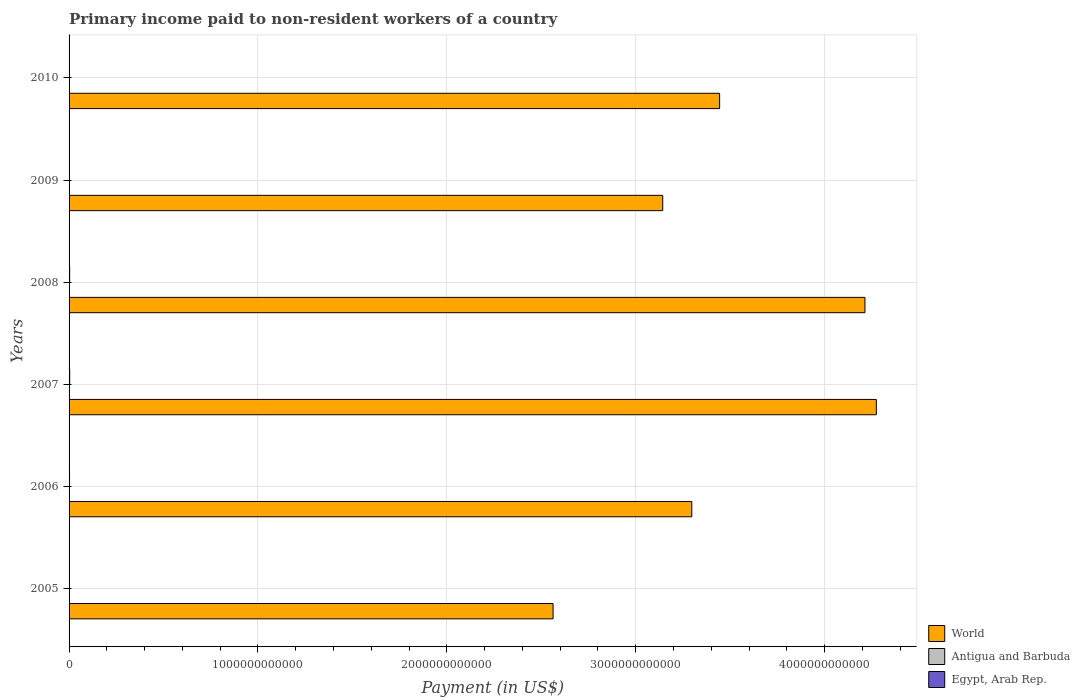How many groups of bars are there?
Provide a short and direct response. 6. Are the number of bars per tick equal to the number of legend labels?
Your answer should be very brief. Yes. How many bars are there on the 3rd tick from the top?
Give a very brief answer. 3. How many bars are there on the 3rd tick from the bottom?
Make the answer very short. 3. What is the label of the 6th group of bars from the top?
Your answer should be compact. 2005. What is the amount paid to workers in Egypt, Arab Rep. in 2006?
Keep it short and to the point. 2.56e+09. Across all years, what is the maximum amount paid to workers in Antigua and Barbuda?
Provide a short and direct response. 2.67e+07. Across all years, what is the minimum amount paid to workers in Antigua and Barbuda?
Keep it short and to the point. 1.11e+07. In which year was the amount paid to workers in World maximum?
Give a very brief answer. 2007. What is the total amount paid to workers in Antigua and Barbuda in the graph?
Provide a short and direct response. 1.11e+08. What is the difference between the amount paid to workers in World in 2008 and that in 2010?
Provide a short and direct response. 7.69e+11. What is the difference between the amount paid to workers in World in 2010 and the amount paid to workers in Egypt, Arab Rep. in 2008?
Your answer should be very brief. 3.44e+12. What is the average amount paid to workers in Antigua and Barbuda per year?
Make the answer very short. 1.85e+07. In the year 2010, what is the difference between the amount paid to workers in Egypt, Arab Rep. and amount paid to workers in World?
Offer a very short reply. -3.44e+12. In how many years, is the amount paid to workers in Egypt, Arab Rep. greater than 600000000000 US$?
Offer a very short reply. 0. What is the ratio of the amount paid to workers in World in 2007 to that in 2008?
Give a very brief answer. 1.01. Is the amount paid to workers in Antigua and Barbuda in 2008 less than that in 2009?
Make the answer very short. No. What is the difference between the highest and the second highest amount paid to workers in World?
Your answer should be compact. 6.03e+1. What is the difference between the highest and the lowest amount paid to workers in World?
Ensure brevity in your answer.  1.71e+12. Is the sum of the amount paid to workers in Antigua and Barbuda in 2007 and 2009 greater than the maximum amount paid to workers in World across all years?
Make the answer very short. No. What does the 1st bar from the top in 2009 represents?
Offer a very short reply. Egypt, Arab Rep. How many bars are there?
Ensure brevity in your answer.  18. Are all the bars in the graph horizontal?
Your answer should be very brief. Yes. How many years are there in the graph?
Your response must be concise. 6. What is the difference between two consecutive major ticks on the X-axis?
Provide a short and direct response. 1.00e+12. Are the values on the major ticks of X-axis written in scientific E-notation?
Offer a very short reply. No. Does the graph contain grids?
Offer a very short reply. Yes. Where does the legend appear in the graph?
Provide a short and direct response. Bottom right. How many legend labels are there?
Give a very brief answer. 3. How are the legend labels stacked?
Provide a short and direct response. Vertical. What is the title of the graph?
Keep it short and to the point. Primary income paid to non-resident workers of a country. Does "St. Vincent and the Grenadines" appear as one of the legend labels in the graph?
Offer a very short reply. No. What is the label or title of the X-axis?
Your answer should be compact. Payment (in US$). What is the Payment (in US$) in World in 2005?
Give a very brief answer. 2.56e+12. What is the Payment (in US$) in Antigua and Barbuda in 2005?
Your answer should be very brief. 1.80e+07. What is the Payment (in US$) in Egypt, Arab Rep. in 2005?
Keep it short and to the point. 1.43e+09. What is the Payment (in US$) of World in 2006?
Keep it short and to the point. 3.30e+12. What is the Payment (in US$) of Antigua and Barbuda in 2006?
Ensure brevity in your answer.  2.67e+07. What is the Payment (in US$) in Egypt, Arab Rep. in 2006?
Make the answer very short. 2.56e+09. What is the Payment (in US$) in World in 2007?
Your answer should be very brief. 4.27e+12. What is the Payment (in US$) of Antigua and Barbuda in 2007?
Your answer should be very brief. 2.58e+07. What is the Payment (in US$) in Egypt, Arab Rep. in 2007?
Offer a terse response. 3.31e+09. What is the Payment (in US$) of World in 2008?
Offer a very short reply. 4.21e+12. What is the Payment (in US$) of Antigua and Barbuda in 2008?
Provide a short and direct response. 1.61e+07. What is the Payment (in US$) of Egypt, Arab Rep. in 2008?
Make the answer very short. 3.07e+09. What is the Payment (in US$) of World in 2009?
Give a very brief answer. 3.14e+12. What is the Payment (in US$) of Antigua and Barbuda in 2009?
Keep it short and to the point. 1.31e+07. What is the Payment (in US$) in Egypt, Arab Rep. in 2009?
Provide a succinct answer. 9.92e+08. What is the Payment (in US$) in World in 2010?
Make the answer very short. 3.44e+12. What is the Payment (in US$) of Antigua and Barbuda in 2010?
Your answer should be very brief. 1.11e+07. What is the Payment (in US$) of Egypt, Arab Rep. in 2010?
Your answer should be compact. 5.34e+08. Across all years, what is the maximum Payment (in US$) of World?
Offer a very short reply. 4.27e+12. Across all years, what is the maximum Payment (in US$) of Antigua and Barbuda?
Keep it short and to the point. 2.67e+07. Across all years, what is the maximum Payment (in US$) in Egypt, Arab Rep.?
Your response must be concise. 3.31e+09. Across all years, what is the minimum Payment (in US$) in World?
Offer a terse response. 2.56e+12. Across all years, what is the minimum Payment (in US$) of Antigua and Barbuda?
Offer a very short reply. 1.11e+07. Across all years, what is the minimum Payment (in US$) in Egypt, Arab Rep.?
Your answer should be very brief. 5.34e+08. What is the total Payment (in US$) in World in the graph?
Your answer should be compact. 2.09e+13. What is the total Payment (in US$) in Antigua and Barbuda in the graph?
Offer a very short reply. 1.11e+08. What is the total Payment (in US$) in Egypt, Arab Rep. in the graph?
Your response must be concise. 1.19e+1. What is the difference between the Payment (in US$) of World in 2005 and that in 2006?
Keep it short and to the point. -7.34e+11. What is the difference between the Payment (in US$) in Antigua and Barbuda in 2005 and that in 2006?
Keep it short and to the point. -8.75e+06. What is the difference between the Payment (in US$) of Egypt, Arab Rep. in 2005 and that in 2006?
Your response must be concise. -1.14e+09. What is the difference between the Payment (in US$) in World in 2005 and that in 2007?
Your answer should be very brief. -1.71e+12. What is the difference between the Payment (in US$) in Antigua and Barbuda in 2005 and that in 2007?
Offer a very short reply. -7.83e+06. What is the difference between the Payment (in US$) in Egypt, Arab Rep. in 2005 and that in 2007?
Ensure brevity in your answer.  -1.88e+09. What is the difference between the Payment (in US$) of World in 2005 and that in 2008?
Give a very brief answer. -1.65e+12. What is the difference between the Payment (in US$) of Antigua and Barbuda in 2005 and that in 2008?
Make the answer very short. 1.85e+06. What is the difference between the Payment (in US$) in Egypt, Arab Rep. in 2005 and that in 2008?
Offer a very short reply. -1.64e+09. What is the difference between the Payment (in US$) of World in 2005 and that in 2009?
Keep it short and to the point. -5.81e+11. What is the difference between the Payment (in US$) in Antigua and Barbuda in 2005 and that in 2009?
Ensure brevity in your answer.  4.85e+06. What is the difference between the Payment (in US$) of Egypt, Arab Rep. in 2005 and that in 2009?
Your response must be concise. 4.34e+08. What is the difference between the Payment (in US$) of World in 2005 and that in 2010?
Ensure brevity in your answer.  -8.82e+11. What is the difference between the Payment (in US$) in Antigua and Barbuda in 2005 and that in 2010?
Offer a very short reply. 6.82e+06. What is the difference between the Payment (in US$) of Egypt, Arab Rep. in 2005 and that in 2010?
Provide a short and direct response. 8.92e+08. What is the difference between the Payment (in US$) in World in 2006 and that in 2007?
Ensure brevity in your answer.  -9.77e+11. What is the difference between the Payment (in US$) of Antigua and Barbuda in 2006 and that in 2007?
Keep it short and to the point. 9.19e+05. What is the difference between the Payment (in US$) of Egypt, Arab Rep. in 2006 and that in 2007?
Your answer should be very brief. -7.49e+08. What is the difference between the Payment (in US$) of World in 2006 and that in 2008?
Your response must be concise. -9.17e+11. What is the difference between the Payment (in US$) in Antigua and Barbuda in 2006 and that in 2008?
Ensure brevity in your answer.  1.06e+07. What is the difference between the Payment (in US$) in Egypt, Arab Rep. in 2006 and that in 2008?
Your answer should be compact. -5.05e+08. What is the difference between the Payment (in US$) in World in 2006 and that in 2009?
Keep it short and to the point. 1.54e+11. What is the difference between the Payment (in US$) of Antigua and Barbuda in 2006 and that in 2009?
Keep it short and to the point. 1.36e+07. What is the difference between the Payment (in US$) in Egypt, Arab Rep. in 2006 and that in 2009?
Offer a terse response. 1.57e+09. What is the difference between the Payment (in US$) of World in 2006 and that in 2010?
Provide a succinct answer. -1.47e+11. What is the difference between the Payment (in US$) of Antigua and Barbuda in 2006 and that in 2010?
Provide a short and direct response. 1.56e+07. What is the difference between the Payment (in US$) of Egypt, Arab Rep. in 2006 and that in 2010?
Keep it short and to the point. 2.03e+09. What is the difference between the Payment (in US$) in World in 2007 and that in 2008?
Offer a very short reply. 6.03e+1. What is the difference between the Payment (in US$) of Antigua and Barbuda in 2007 and that in 2008?
Your answer should be compact. 9.68e+06. What is the difference between the Payment (in US$) in Egypt, Arab Rep. in 2007 and that in 2008?
Provide a short and direct response. 2.44e+08. What is the difference between the Payment (in US$) of World in 2007 and that in 2009?
Ensure brevity in your answer.  1.13e+12. What is the difference between the Payment (in US$) of Antigua and Barbuda in 2007 and that in 2009?
Keep it short and to the point. 1.27e+07. What is the difference between the Payment (in US$) in Egypt, Arab Rep. in 2007 and that in 2009?
Provide a short and direct response. 2.32e+09. What is the difference between the Payment (in US$) in World in 2007 and that in 2010?
Provide a succinct answer. 8.30e+11. What is the difference between the Payment (in US$) of Antigua and Barbuda in 2007 and that in 2010?
Offer a terse response. 1.47e+07. What is the difference between the Payment (in US$) in Egypt, Arab Rep. in 2007 and that in 2010?
Make the answer very short. 2.78e+09. What is the difference between the Payment (in US$) of World in 2008 and that in 2009?
Make the answer very short. 1.07e+12. What is the difference between the Payment (in US$) of Antigua and Barbuda in 2008 and that in 2009?
Your response must be concise. 3.00e+06. What is the difference between the Payment (in US$) in Egypt, Arab Rep. in 2008 and that in 2009?
Give a very brief answer. 2.07e+09. What is the difference between the Payment (in US$) in World in 2008 and that in 2010?
Your answer should be very brief. 7.69e+11. What is the difference between the Payment (in US$) in Antigua and Barbuda in 2008 and that in 2010?
Offer a terse response. 4.97e+06. What is the difference between the Payment (in US$) of Egypt, Arab Rep. in 2008 and that in 2010?
Your answer should be very brief. 2.53e+09. What is the difference between the Payment (in US$) of World in 2009 and that in 2010?
Ensure brevity in your answer.  -3.01e+11. What is the difference between the Payment (in US$) of Antigua and Barbuda in 2009 and that in 2010?
Offer a terse response. 1.97e+06. What is the difference between the Payment (in US$) in Egypt, Arab Rep. in 2009 and that in 2010?
Provide a short and direct response. 4.58e+08. What is the difference between the Payment (in US$) of World in 2005 and the Payment (in US$) of Antigua and Barbuda in 2006?
Your response must be concise. 2.56e+12. What is the difference between the Payment (in US$) in World in 2005 and the Payment (in US$) in Egypt, Arab Rep. in 2006?
Make the answer very short. 2.56e+12. What is the difference between the Payment (in US$) in Antigua and Barbuda in 2005 and the Payment (in US$) in Egypt, Arab Rep. in 2006?
Ensure brevity in your answer.  -2.54e+09. What is the difference between the Payment (in US$) of World in 2005 and the Payment (in US$) of Antigua and Barbuda in 2007?
Provide a succinct answer. 2.56e+12. What is the difference between the Payment (in US$) in World in 2005 and the Payment (in US$) in Egypt, Arab Rep. in 2007?
Offer a very short reply. 2.56e+12. What is the difference between the Payment (in US$) in Antigua and Barbuda in 2005 and the Payment (in US$) in Egypt, Arab Rep. in 2007?
Give a very brief answer. -3.29e+09. What is the difference between the Payment (in US$) in World in 2005 and the Payment (in US$) in Antigua and Barbuda in 2008?
Give a very brief answer. 2.56e+12. What is the difference between the Payment (in US$) in World in 2005 and the Payment (in US$) in Egypt, Arab Rep. in 2008?
Provide a short and direct response. 2.56e+12. What is the difference between the Payment (in US$) of Antigua and Barbuda in 2005 and the Payment (in US$) of Egypt, Arab Rep. in 2008?
Your answer should be very brief. -3.05e+09. What is the difference between the Payment (in US$) in World in 2005 and the Payment (in US$) in Antigua and Barbuda in 2009?
Keep it short and to the point. 2.56e+12. What is the difference between the Payment (in US$) in World in 2005 and the Payment (in US$) in Egypt, Arab Rep. in 2009?
Give a very brief answer. 2.56e+12. What is the difference between the Payment (in US$) of Antigua and Barbuda in 2005 and the Payment (in US$) of Egypt, Arab Rep. in 2009?
Give a very brief answer. -9.74e+08. What is the difference between the Payment (in US$) of World in 2005 and the Payment (in US$) of Antigua and Barbuda in 2010?
Your answer should be compact. 2.56e+12. What is the difference between the Payment (in US$) in World in 2005 and the Payment (in US$) in Egypt, Arab Rep. in 2010?
Provide a succinct answer. 2.56e+12. What is the difference between the Payment (in US$) in Antigua and Barbuda in 2005 and the Payment (in US$) in Egypt, Arab Rep. in 2010?
Give a very brief answer. -5.16e+08. What is the difference between the Payment (in US$) in World in 2006 and the Payment (in US$) in Antigua and Barbuda in 2007?
Make the answer very short. 3.30e+12. What is the difference between the Payment (in US$) in World in 2006 and the Payment (in US$) in Egypt, Arab Rep. in 2007?
Offer a terse response. 3.29e+12. What is the difference between the Payment (in US$) in Antigua and Barbuda in 2006 and the Payment (in US$) in Egypt, Arab Rep. in 2007?
Give a very brief answer. -3.28e+09. What is the difference between the Payment (in US$) in World in 2006 and the Payment (in US$) in Antigua and Barbuda in 2008?
Ensure brevity in your answer.  3.30e+12. What is the difference between the Payment (in US$) in World in 2006 and the Payment (in US$) in Egypt, Arab Rep. in 2008?
Offer a terse response. 3.29e+12. What is the difference between the Payment (in US$) in Antigua and Barbuda in 2006 and the Payment (in US$) in Egypt, Arab Rep. in 2008?
Your response must be concise. -3.04e+09. What is the difference between the Payment (in US$) of World in 2006 and the Payment (in US$) of Antigua and Barbuda in 2009?
Offer a terse response. 3.30e+12. What is the difference between the Payment (in US$) of World in 2006 and the Payment (in US$) of Egypt, Arab Rep. in 2009?
Keep it short and to the point. 3.30e+12. What is the difference between the Payment (in US$) of Antigua and Barbuda in 2006 and the Payment (in US$) of Egypt, Arab Rep. in 2009?
Ensure brevity in your answer.  -9.65e+08. What is the difference between the Payment (in US$) in World in 2006 and the Payment (in US$) in Antigua and Barbuda in 2010?
Your answer should be very brief. 3.30e+12. What is the difference between the Payment (in US$) of World in 2006 and the Payment (in US$) of Egypt, Arab Rep. in 2010?
Offer a very short reply. 3.30e+12. What is the difference between the Payment (in US$) of Antigua and Barbuda in 2006 and the Payment (in US$) of Egypt, Arab Rep. in 2010?
Provide a succinct answer. -5.07e+08. What is the difference between the Payment (in US$) of World in 2007 and the Payment (in US$) of Antigua and Barbuda in 2008?
Your response must be concise. 4.27e+12. What is the difference between the Payment (in US$) of World in 2007 and the Payment (in US$) of Egypt, Arab Rep. in 2008?
Provide a succinct answer. 4.27e+12. What is the difference between the Payment (in US$) of Antigua and Barbuda in 2007 and the Payment (in US$) of Egypt, Arab Rep. in 2008?
Your response must be concise. -3.04e+09. What is the difference between the Payment (in US$) of World in 2007 and the Payment (in US$) of Antigua and Barbuda in 2009?
Make the answer very short. 4.27e+12. What is the difference between the Payment (in US$) in World in 2007 and the Payment (in US$) in Egypt, Arab Rep. in 2009?
Offer a terse response. 4.27e+12. What is the difference between the Payment (in US$) of Antigua and Barbuda in 2007 and the Payment (in US$) of Egypt, Arab Rep. in 2009?
Provide a succinct answer. -9.66e+08. What is the difference between the Payment (in US$) in World in 2007 and the Payment (in US$) in Antigua and Barbuda in 2010?
Provide a short and direct response. 4.27e+12. What is the difference between the Payment (in US$) in World in 2007 and the Payment (in US$) in Egypt, Arab Rep. in 2010?
Your answer should be compact. 4.27e+12. What is the difference between the Payment (in US$) of Antigua and Barbuda in 2007 and the Payment (in US$) of Egypt, Arab Rep. in 2010?
Your answer should be very brief. -5.08e+08. What is the difference between the Payment (in US$) of World in 2008 and the Payment (in US$) of Antigua and Barbuda in 2009?
Provide a short and direct response. 4.21e+12. What is the difference between the Payment (in US$) of World in 2008 and the Payment (in US$) of Egypt, Arab Rep. in 2009?
Give a very brief answer. 4.21e+12. What is the difference between the Payment (in US$) in Antigua and Barbuda in 2008 and the Payment (in US$) in Egypt, Arab Rep. in 2009?
Your response must be concise. -9.76e+08. What is the difference between the Payment (in US$) in World in 2008 and the Payment (in US$) in Antigua and Barbuda in 2010?
Offer a very short reply. 4.21e+12. What is the difference between the Payment (in US$) of World in 2008 and the Payment (in US$) of Egypt, Arab Rep. in 2010?
Keep it short and to the point. 4.21e+12. What is the difference between the Payment (in US$) in Antigua and Barbuda in 2008 and the Payment (in US$) in Egypt, Arab Rep. in 2010?
Make the answer very short. -5.18e+08. What is the difference between the Payment (in US$) of World in 2009 and the Payment (in US$) of Antigua and Barbuda in 2010?
Provide a short and direct response. 3.14e+12. What is the difference between the Payment (in US$) in World in 2009 and the Payment (in US$) in Egypt, Arab Rep. in 2010?
Your response must be concise. 3.14e+12. What is the difference between the Payment (in US$) of Antigua and Barbuda in 2009 and the Payment (in US$) of Egypt, Arab Rep. in 2010?
Ensure brevity in your answer.  -5.21e+08. What is the average Payment (in US$) of World per year?
Provide a short and direct response. 3.49e+12. What is the average Payment (in US$) in Antigua and Barbuda per year?
Make the answer very short. 1.85e+07. What is the average Payment (in US$) of Egypt, Arab Rep. per year?
Provide a short and direct response. 1.98e+09. In the year 2005, what is the difference between the Payment (in US$) of World and Payment (in US$) of Antigua and Barbuda?
Ensure brevity in your answer.  2.56e+12. In the year 2005, what is the difference between the Payment (in US$) of World and Payment (in US$) of Egypt, Arab Rep.?
Your answer should be compact. 2.56e+12. In the year 2005, what is the difference between the Payment (in US$) of Antigua and Barbuda and Payment (in US$) of Egypt, Arab Rep.?
Ensure brevity in your answer.  -1.41e+09. In the year 2006, what is the difference between the Payment (in US$) of World and Payment (in US$) of Antigua and Barbuda?
Ensure brevity in your answer.  3.30e+12. In the year 2006, what is the difference between the Payment (in US$) of World and Payment (in US$) of Egypt, Arab Rep.?
Offer a very short reply. 3.29e+12. In the year 2006, what is the difference between the Payment (in US$) in Antigua and Barbuda and Payment (in US$) in Egypt, Arab Rep.?
Your response must be concise. -2.53e+09. In the year 2007, what is the difference between the Payment (in US$) of World and Payment (in US$) of Antigua and Barbuda?
Provide a short and direct response. 4.27e+12. In the year 2007, what is the difference between the Payment (in US$) of World and Payment (in US$) of Egypt, Arab Rep.?
Your answer should be very brief. 4.27e+12. In the year 2007, what is the difference between the Payment (in US$) in Antigua and Barbuda and Payment (in US$) in Egypt, Arab Rep.?
Keep it short and to the point. -3.28e+09. In the year 2008, what is the difference between the Payment (in US$) in World and Payment (in US$) in Antigua and Barbuda?
Ensure brevity in your answer.  4.21e+12. In the year 2008, what is the difference between the Payment (in US$) of World and Payment (in US$) of Egypt, Arab Rep.?
Offer a terse response. 4.21e+12. In the year 2008, what is the difference between the Payment (in US$) of Antigua and Barbuda and Payment (in US$) of Egypt, Arab Rep.?
Your answer should be compact. -3.05e+09. In the year 2009, what is the difference between the Payment (in US$) in World and Payment (in US$) in Antigua and Barbuda?
Make the answer very short. 3.14e+12. In the year 2009, what is the difference between the Payment (in US$) of World and Payment (in US$) of Egypt, Arab Rep.?
Your response must be concise. 3.14e+12. In the year 2009, what is the difference between the Payment (in US$) of Antigua and Barbuda and Payment (in US$) of Egypt, Arab Rep.?
Your answer should be very brief. -9.79e+08. In the year 2010, what is the difference between the Payment (in US$) in World and Payment (in US$) in Antigua and Barbuda?
Offer a very short reply. 3.44e+12. In the year 2010, what is the difference between the Payment (in US$) in World and Payment (in US$) in Egypt, Arab Rep.?
Keep it short and to the point. 3.44e+12. In the year 2010, what is the difference between the Payment (in US$) in Antigua and Barbuda and Payment (in US$) in Egypt, Arab Rep.?
Your response must be concise. -5.23e+08. What is the ratio of the Payment (in US$) in World in 2005 to that in 2006?
Your answer should be very brief. 0.78. What is the ratio of the Payment (in US$) of Antigua and Barbuda in 2005 to that in 2006?
Provide a short and direct response. 0.67. What is the ratio of the Payment (in US$) in Egypt, Arab Rep. in 2005 to that in 2006?
Keep it short and to the point. 0.56. What is the ratio of the Payment (in US$) of World in 2005 to that in 2007?
Offer a terse response. 0.6. What is the ratio of the Payment (in US$) in Antigua and Barbuda in 2005 to that in 2007?
Your answer should be compact. 0.7. What is the ratio of the Payment (in US$) in Egypt, Arab Rep. in 2005 to that in 2007?
Provide a succinct answer. 0.43. What is the ratio of the Payment (in US$) of World in 2005 to that in 2008?
Give a very brief answer. 0.61. What is the ratio of the Payment (in US$) in Antigua and Barbuda in 2005 to that in 2008?
Offer a terse response. 1.11. What is the ratio of the Payment (in US$) in Egypt, Arab Rep. in 2005 to that in 2008?
Provide a short and direct response. 0.47. What is the ratio of the Payment (in US$) of World in 2005 to that in 2009?
Make the answer very short. 0.82. What is the ratio of the Payment (in US$) in Antigua and Barbuda in 2005 to that in 2009?
Your answer should be very brief. 1.37. What is the ratio of the Payment (in US$) of Egypt, Arab Rep. in 2005 to that in 2009?
Your answer should be compact. 1.44. What is the ratio of the Payment (in US$) of World in 2005 to that in 2010?
Keep it short and to the point. 0.74. What is the ratio of the Payment (in US$) of Antigua and Barbuda in 2005 to that in 2010?
Provide a succinct answer. 1.61. What is the ratio of the Payment (in US$) in Egypt, Arab Rep. in 2005 to that in 2010?
Offer a very short reply. 2.67. What is the ratio of the Payment (in US$) of World in 2006 to that in 2007?
Provide a short and direct response. 0.77. What is the ratio of the Payment (in US$) in Antigua and Barbuda in 2006 to that in 2007?
Make the answer very short. 1.04. What is the ratio of the Payment (in US$) of Egypt, Arab Rep. in 2006 to that in 2007?
Offer a very short reply. 0.77. What is the ratio of the Payment (in US$) of World in 2006 to that in 2008?
Ensure brevity in your answer.  0.78. What is the ratio of the Payment (in US$) in Antigua and Barbuda in 2006 to that in 2008?
Offer a very short reply. 1.66. What is the ratio of the Payment (in US$) in Egypt, Arab Rep. in 2006 to that in 2008?
Make the answer very short. 0.84. What is the ratio of the Payment (in US$) in World in 2006 to that in 2009?
Your answer should be compact. 1.05. What is the ratio of the Payment (in US$) in Antigua and Barbuda in 2006 to that in 2009?
Your answer should be compact. 2.04. What is the ratio of the Payment (in US$) in Egypt, Arab Rep. in 2006 to that in 2009?
Offer a terse response. 2.58. What is the ratio of the Payment (in US$) of World in 2006 to that in 2010?
Make the answer very short. 0.96. What is the ratio of the Payment (in US$) in Antigua and Barbuda in 2006 to that in 2010?
Provide a short and direct response. 2.4. What is the ratio of the Payment (in US$) in Egypt, Arab Rep. in 2006 to that in 2010?
Provide a succinct answer. 4.8. What is the ratio of the Payment (in US$) in World in 2007 to that in 2008?
Keep it short and to the point. 1.01. What is the ratio of the Payment (in US$) of Antigua and Barbuda in 2007 to that in 2008?
Provide a short and direct response. 1.6. What is the ratio of the Payment (in US$) of Egypt, Arab Rep. in 2007 to that in 2008?
Make the answer very short. 1.08. What is the ratio of the Payment (in US$) in World in 2007 to that in 2009?
Provide a succinct answer. 1.36. What is the ratio of the Payment (in US$) of Antigua and Barbuda in 2007 to that in 2009?
Keep it short and to the point. 1.97. What is the ratio of the Payment (in US$) of Egypt, Arab Rep. in 2007 to that in 2009?
Provide a short and direct response. 3.34. What is the ratio of the Payment (in US$) of World in 2007 to that in 2010?
Provide a short and direct response. 1.24. What is the ratio of the Payment (in US$) of Antigua and Barbuda in 2007 to that in 2010?
Make the answer very short. 2.32. What is the ratio of the Payment (in US$) in Egypt, Arab Rep. in 2007 to that in 2010?
Ensure brevity in your answer.  6.2. What is the ratio of the Payment (in US$) of World in 2008 to that in 2009?
Your answer should be very brief. 1.34. What is the ratio of the Payment (in US$) in Antigua and Barbuda in 2008 to that in 2009?
Ensure brevity in your answer.  1.23. What is the ratio of the Payment (in US$) in Egypt, Arab Rep. in 2008 to that in 2009?
Give a very brief answer. 3.09. What is the ratio of the Payment (in US$) of World in 2008 to that in 2010?
Ensure brevity in your answer.  1.22. What is the ratio of the Payment (in US$) of Antigua and Barbuda in 2008 to that in 2010?
Keep it short and to the point. 1.45. What is the ratio of the Payment (in US$) of Egypt, Arab Rep. in 2008 to that in 2010?
Your answer should be compact. 5.74. What is the ratio of the Payment (in US$) of World in 2009 to that in 2010?
Provide a short and direct response. 0.91. What is the ratio of the Payment (in US$) of Antigua and Barbuda in 2009 to that in 2010?
Ensure brevity in your answer.  1.18. What is the ratio of the Payment (in US$) in Egypt, Arab Rep. in 2009 to that in 2010?
Offer a terse response. 1.86. What is the difference between the highest and the second highest Payment (in US$) of World?
Your response must be concise. 6.03e+1. What is the difference between the highest and the second highest Payment (in US$) in Antigua and Barbuda?
Ensure brevity in your answer.  9.19e+05. What is the difference between the highest and the second highest Payment (in US$) of Egypt, Arab Rep.?
Offer a terse response. 2.44e+08. What is the difference between the highest and the lowest Payment (in US$) in World?
Provide a succinct answer. 1.71e+12. What is the difference between the highest and the lowest Payment (in US$) of Antigua and Barbuda?
Provide a short and direct response. 1.56e+07. What is the difference between the highest and the lowest Payment (in US$) in Egypt, Arab Rep.?
Give a very brief answer. 2.78e+09. 